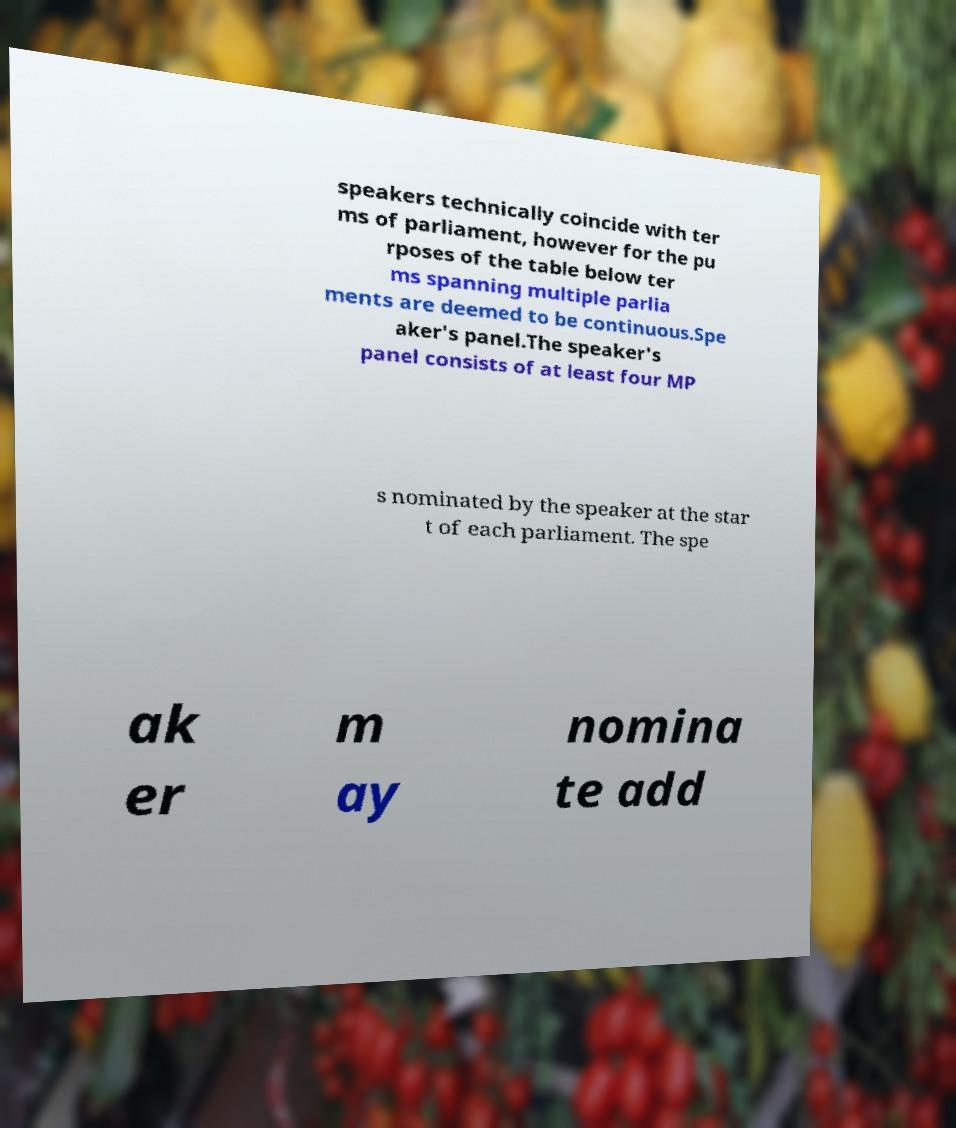Can you accurately transcribe the text from the provided image for me? speakers technically coincide with ter ms of parliament, however for the pu rposes of the table below ter ms spanning multiple parlia ments are deemed to be continuous.Spe aker's panel.The speaker's panel consists of at least four MP s nominated by the speaker at the star t of each parliament. The spe ak er m ay nomina te add 